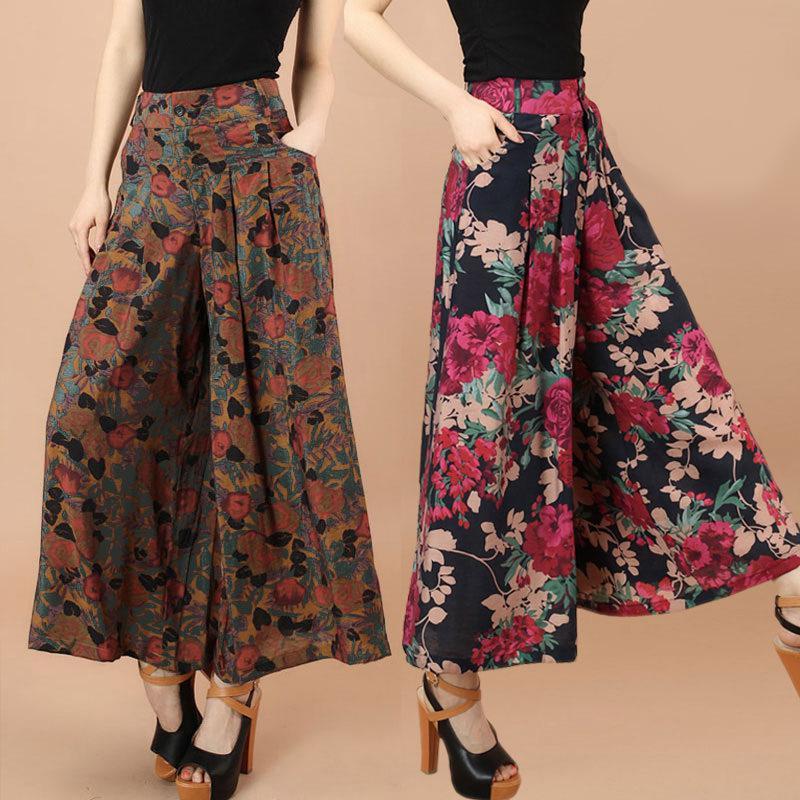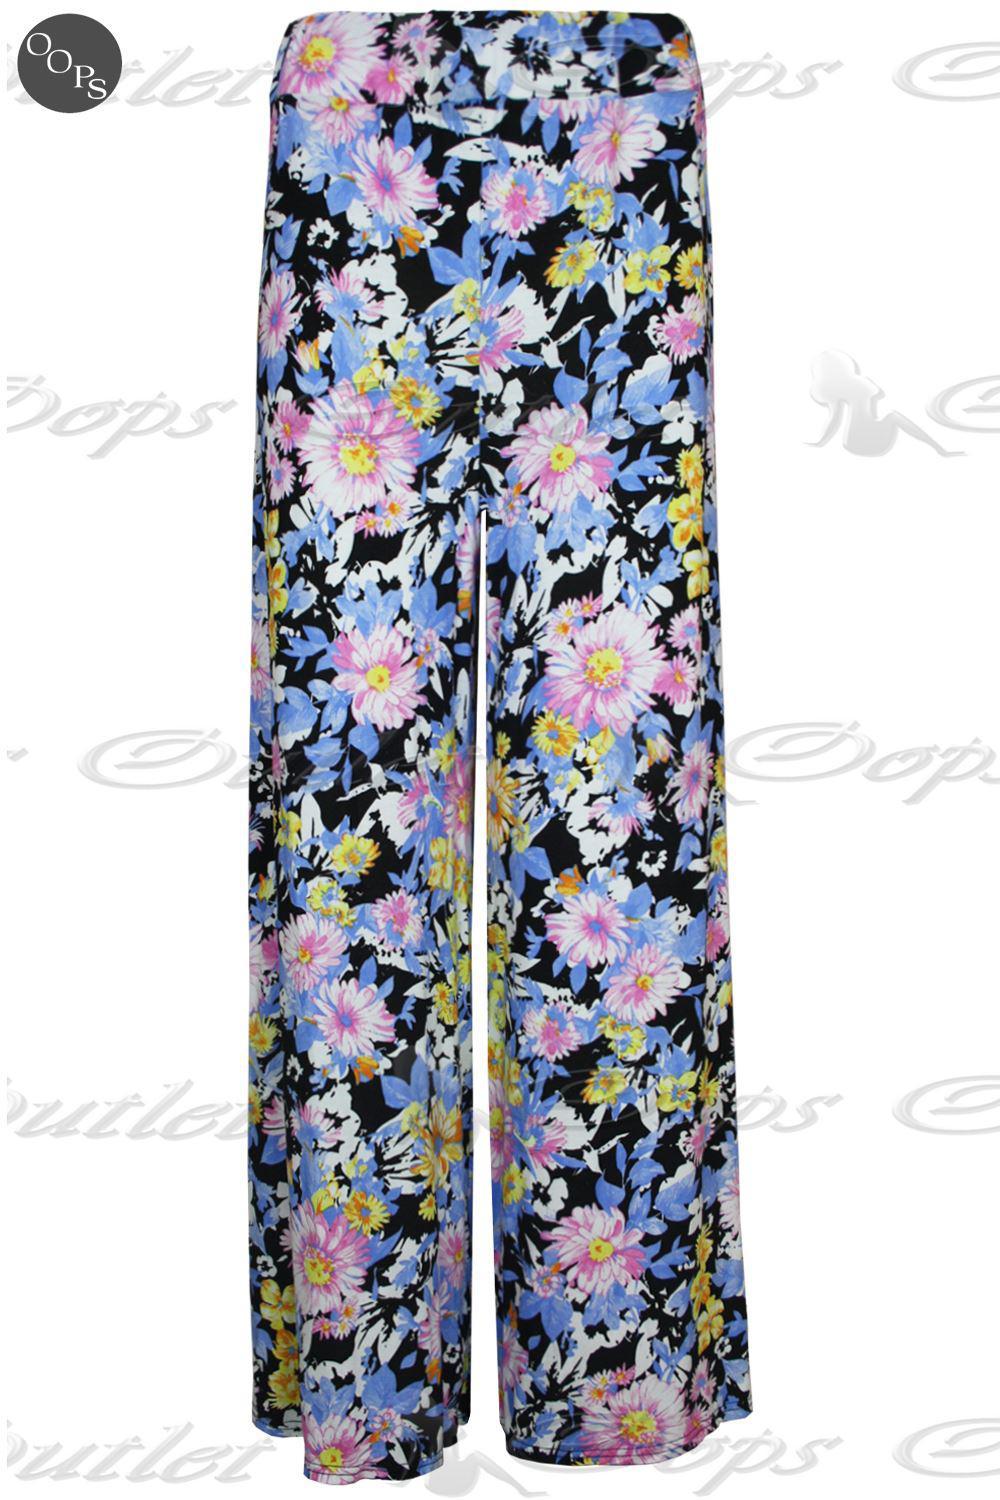The first image is the image on the left, the second image is the image on the right. Evaluate the accuracy of this statement regarding the images: "A person is wearing the clothing on the right.". Is it true? Answer yes or no. No. 